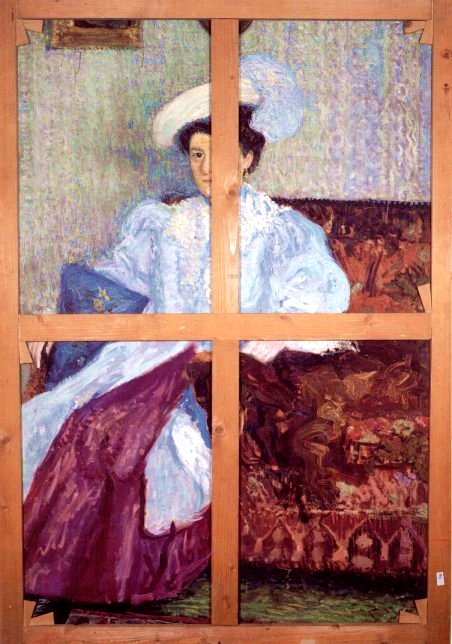Can you describe the mood of the painting? The mood of this painting is serene and reflective. The woman's tranquil expression and distant gaze suggest a moment of contemplation or quiet introspection. The soft, warm colors and delicate brushstrokes enhance a feeling of calmness, while the rich and vibrant hues add a touch of liveliness and sophistication to the overall scene. The interplay between the cool tones of her garment and the warm tones of the hat and couch creates a balanced, harmonious composition. What might the woman be thinking about? It's intriguing to ponder what the woman in the painting might be thinking about. Given her serene expression and distant gaze, she might be recalling fond memories, contemplating her future, or even daydreaming about a distant place or person. The enigmatic nature of her expression allows viewers to project their own interpretations, adding depth and personal connection to the artwork. What would this scene look like if it were painted in a modern, abstract style? If this scene were painted in a modern, abstract style, it might transition into a more fragmented composition with bold, contrasting colors and dynamic shapes. The woman's figure could be reduced to a series of geometric forms, her face perhaps represented by overlapping planes of color, each evoking different emotions. The dress and couch might merge into sweeping curves and angular lines, creating an energetic flow across the canvas. The strong lines of the wooden beams might be interpreted as thick, bold strokes, emphasizing the division and connection of the different panels. Despite its abstract nature, the essence of the original scene's tranquility and depth could still be preserved in the choice of colors and the overall composition. 